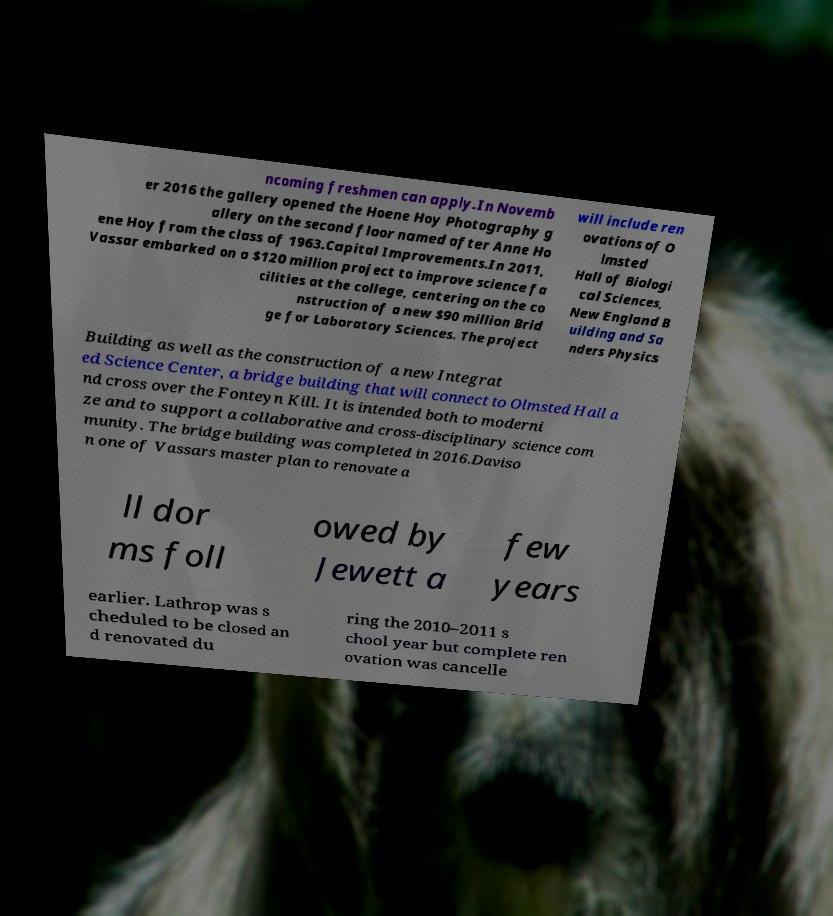There's text embedded in this image that I need extracted. Can you transcribe it verbatim? ncoming freshmen can apply.In Novemb er 2016 the gallery opened the Hoene Hoy Photography g allery on the second floor named after Anne Ho ene Hoy from the class of 1963.Capital Improvements.In 2011, Vassar embarked on a $120 million project to improve science fa cilities at the college, centering on the co nstruction of a new $90 million Brid ge for Laboratory Sciences. The project will include ren ovations of O lmsted Hall of Biologi cal Sciences, New England B uilding and Sa nders Physics Building as well as the construction of a new Integrat ed Science Center, a bridge building that will connect to Olmsted Hall a nd cross over the Fonteyn Kill. It is intended both to moderni ze and to support a collaborative and cross-disciplinary science com munity. The bridge building was completed in 2016.Daviso n one of Vassars master plan to renovate a ll dor ms foll owed by Jewett a few years earlier. Lathrop was s cheduled to be closed an d renovated du ring the 2010–2011 s chool year but complete ren ovation was cancelle 